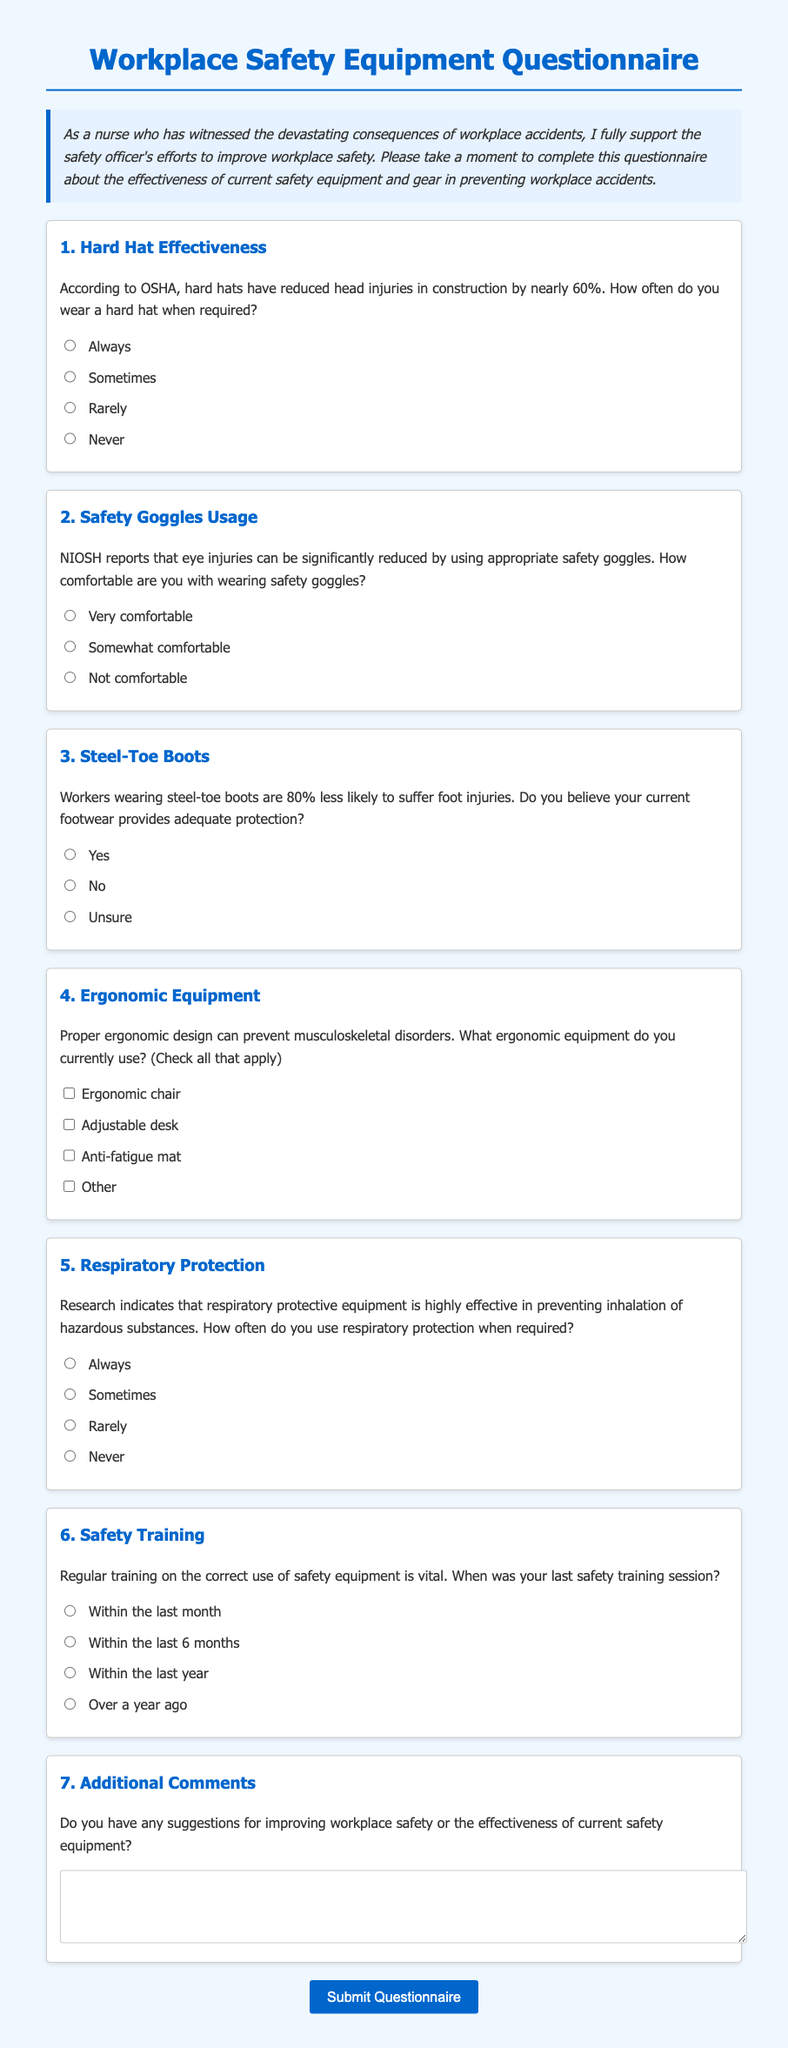What is the title of the questionnaire? The title is specified at the beginning of the document, it indicates the purpose of the content.
Answer: Workplace Safety Equipment Questionnaire How often do participants wear a hard hat when required? This question asks for a frequency response regarding hard hat usage from the provided options in the document.
Answer: Always, Sometimes, Rarely, Never What percentage reduction in head injuries do hard hats provide according to OSHA? This percentage indicates the effectiveness of hard hats in preventing injuries, mentioned in the document.
Answer: Nearly 60% What type of protective gear is mentioned for preventing eye injuries? The type of gear is specified in the context of reducing eye injuries, based on guidelines from NIOSH.
Answer: Safety goggles What ergonomic equipment is listed as a suggestion? This question seeks to identify the types of ergonomic equipment that could be used as stated in the document.
Answer: Ergonomic chair, Adjustable desk, Anti-fatigue mat, Other How often do participants use respiratory protection when required? This question focuses on the frequency of respiratory protection usage, which is an important safety measure included in the document.
Answer: Always, Sometimes, Rarely, Never When should safety training sessions ideally take place? The timing related to safety training sessions is crucial for workplace safety and is outlined in the questionnaire.
Answer: Within the last month, Within the last 6 months, Within the last year, Over a year ago What is the purpose of the questionnaire? This question seeks to clarify the primary goal of the document as stated in the introduction.
Answer: To assess the effectiveness of current safety equipment and gear in preventing workplace accidents Do participants have an option to provide additional comments? This question inquires if there is a provision for open feedback within the questionnaire.
Answer: Yes 